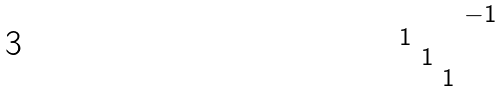<formula> <loc_0><loc_0><loc_500><loc_500>\begin{smallmatrix} & & & - 1 \\ 1 & & & \\ & 1 & & \\ & & 1 & \end{smallmatrix}</formula> 